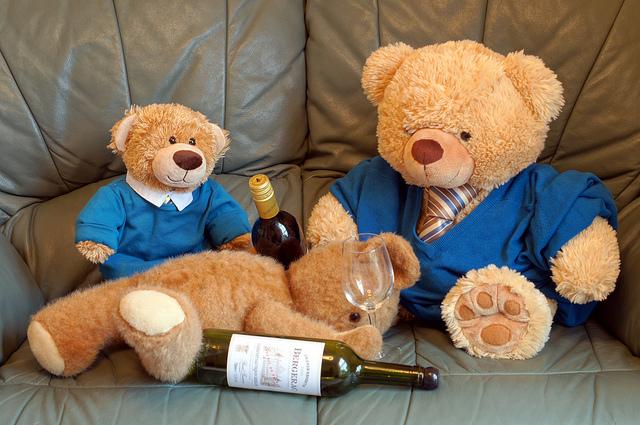How many paw pads do you count?
Concise answer only. 3. IS the passed out bear wearing any blue?
Keep it brief. No. What have the bears been doing?
Be succinct. Drinking. Is this for a child?
Write a very short answer. No. Is this picture meant to be funny?
Answer briefly. Yes. 